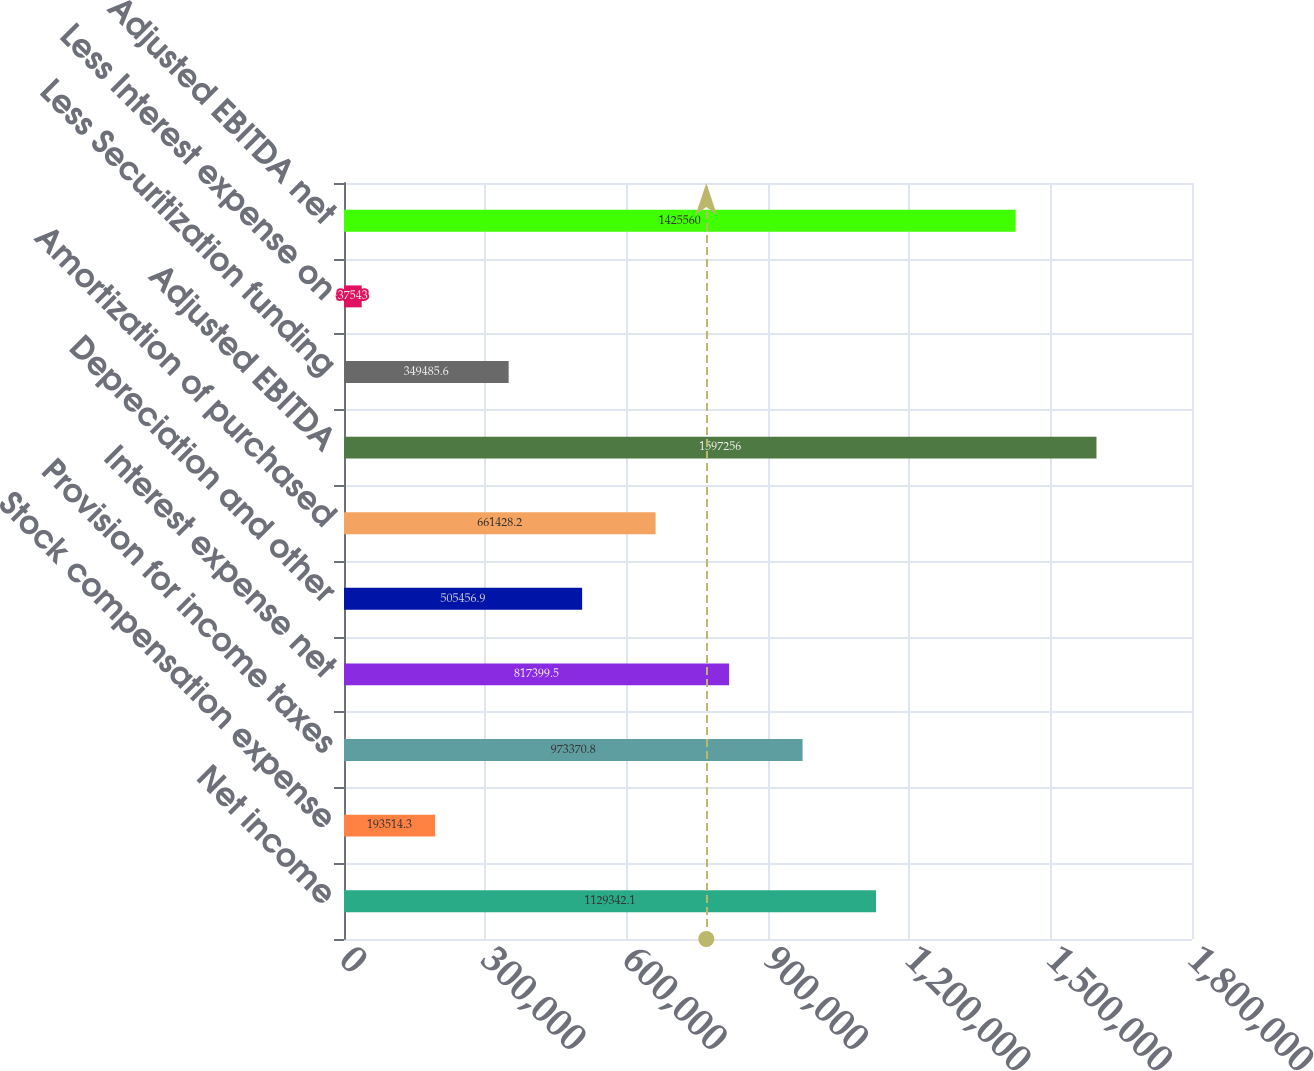Convert chart to OTSL. <chart><loc_0><loc_0><loc_500><loc_500><bar_chart><fcel>Net income<fcel>Stock compensation expense<fcel>Provision for income taxes<fcel>Interest expense net<fcel>Depreciation and other<fcel>Amortization of purchased<fcel>Adjusted EBITDA<fcel>Less Securitization funding<fcel>Less Interest expense on<fcel>Adjusted EBITDA net<nl><fcel>1.12934e+06<fcel>193514<fcel>973371<fcel>817400<fcel>505457<fcel>661428<fcel>1.59726e+06<fcel>349486<fcel>37543<fcel>1.42556e+06<nl></chart> 